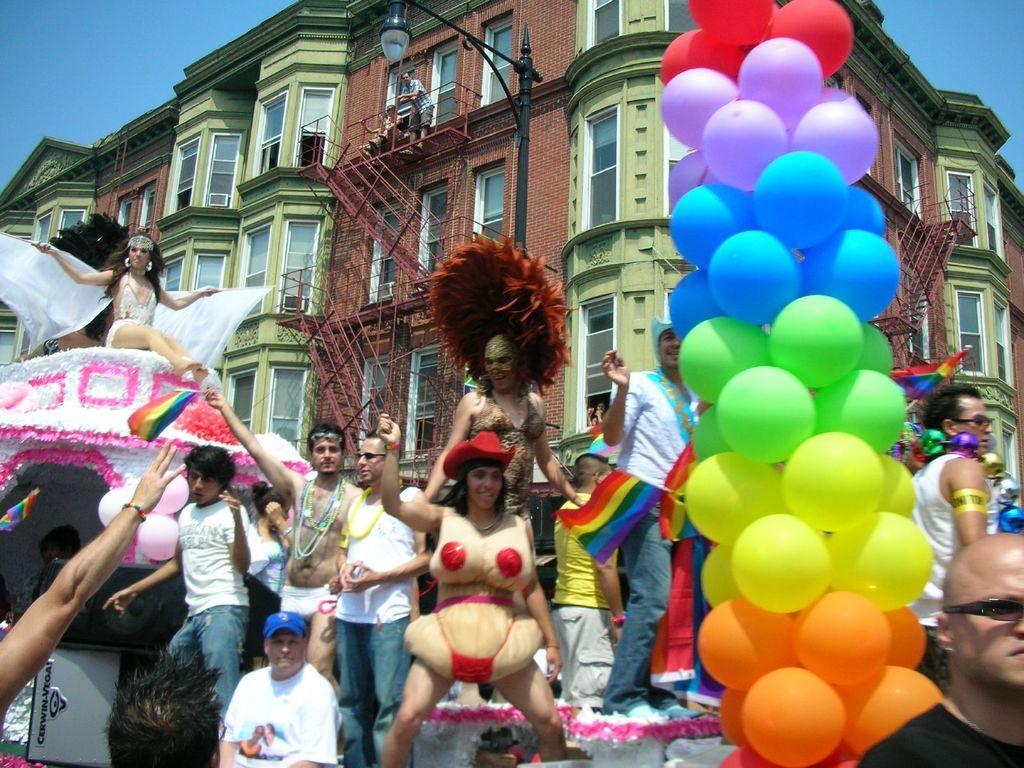Describe this image in one or two sentences. In this image we can see many people and few people holding some objects in their hands. There is a street light in the image. We can see the sky at the either sides of the image. There are many balloons in different colors. We can see a person standing on the building. We can see a building and it is having many windows. 